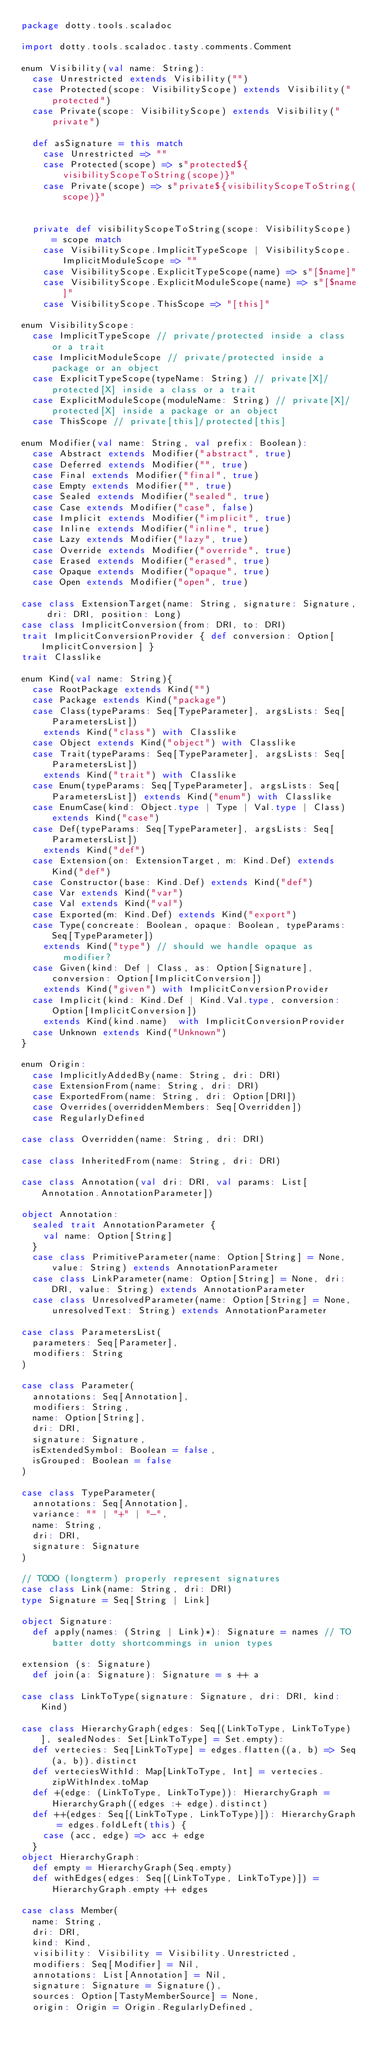Convert code to text. <code><loc_0><loc_0><loc_500><loc_500><_Scala_>package dotty.tools.scaladoc

import dotty.tools.scaladoc.tasty.comments.Comment

enum Visibility(val name: String):
  case Unrestricted extends Visibility("")
  case Protected(scope: VisibilityScope) extends Visibility("protected")
  case Private(scope: VisibilityScope) extends Visibility("private")

  def asSignature = this match
    case Unrestricted => ""
    case Protected(scope) => s"protected${visibilityScopeToString(scope)}"
    case Private(scope) => s"private${visibilityScopeToString(scope)}"


  private def visibilityScopeToString(scope: VisibilityScope) = scope match
    case VisibilityScope.ImplicitTypeScope | VisibilityScope.ImplicitModuleScope => ""
    case VisibilityScope.ExplicitTypeScope(name) => s"[$name]"
    case VisibilityScope.ExplicitModuleScope(name) => s"[$name]"
    case VisibilityScope.ThisScope => "[this]"

enum VisibilityScope:
  case ImplicitTypeScope // private/protected inside a class or a trait
  case ImplicitModuleScope // private/protected inside a package or an object
  case ExplicitTypeScope(typeName: String) // private[X]/protected[X] inside a class or a trait
  case ExplicitModuleScope(moduleName: String) // private[X]/protected[X] inside a package or an object
  case ThisScope // private[this]/protected[this]

enum Modifier(val name: String, val prefix: Boolean):
  case Abstract extends Modifier("abstract", true)
  case Deferred extends Modifier("", true)
  case Final extends Modifier("final", true)
  case Empty extends Modifier("", true)
  case Sealed extends Modifier("sealed", true)
  case Case extends Modifier("case", false)
  case Implicit extends Modifier("implicit", true)
  case Inline extends Modifier("inline", true)
  case Lazy extends Modifier("lazy", true)
  case Override extends Modifier("override", true)
  case Erased extends Modifier("erased", true)
  case Opaque extends Modifier("opaque", true)
  case Open extends Modifier("open", true)

case class ExtensionTarget(name: String, signature: Signature, dri: DRI, position: Long)
case class ImplicitConversion(from: DRI, to: DRI)
trait ImplicitConversionProvider { def conversion: Option[ImplicitConversion] }
trait Classlike

enum Kind(val name: String){
  case RootPackage extends Kind("")
  case Package extends Kind("package")
  case Class(typeParams: Seq[TypeParameter], argsLists: Seq[ParametersList])
    extends Kind("class") with Classlike
  case Object extends Kind("object") with Classlike
  case Trait(typeParams: Seq[TypeParameter], argsLists: Seq[ParametersList])
    extends Kind("trait") with Classlike
  case Enum(typeParams: Seq[TypeParameter], argsLists: Seq[ParametersList]) extends Kind("enum") with Classlike
  case EnumCase(kind: Object.type | Type | Val.type | Class) extends Kind("case")
  case Def(typeParams: Seq[TypeParameter], argsLists: Seq[ParametersList])
    extends Kind("def")
  case Extension(on: ExtensionTarget, m: Kind.Def) extends Kind("def")
  case Constructor(base: Kind.Def) extends Kind("def")
  case Var extends Kind("var")
  case Val extends Kind("val")
  case Exported(m: Kind.Def) extends Kind("export")
  case Type(concreate: Boolean, opaque: Boolean, typeParams: Seq[TypeParameter])
    extends Kind("type") // should we handle opaque as modifier?
  case Given(kind: Def | Class, as: Option[Signature], conversion: Option[ImplicitConversion])
    extends Kind("given") with ImplicitConversionProvider
  case Implicit(kind: Kind.Def | Kind.Val.type, conversion: Option[ImplicitConversion])
    extends Kind(kind.name)  with ImplicitConversionProvider
  case Unknown extends Kind("Unknown")
}

enum Origin:
  case ImplicitlyAddedBy(name: String, dri: DRI)
  case ExtensionFrom(name: String, dri: DRI)
  case ExportedFrom(name: String, dri: Option[DRI])
  case Overrides(overriddenMembers: Seq[Overridden])
  case RegularlyDefined

case class Overridden(name: String, dri: DRI)

case class InheritedFrom(name: String, dri: DRI)

case class Annotation(val dri: DRI, val params: List[Annotation.AnnotationParameter])

object Annotation:
  sealed trait AnnotationParameter {
    val name: Option[String]
  }
  case class PrimitiveParameter(name: Option[String] = None, value: String) extends AnnotationParameter
  case class LinkParameter(name: Option[String] = None, dri: DRI, value: String) extends AnnotationParameter
  case class UnresolvedParameter(name: Option[String] = None, unresolvedText: String) extends AnnotationParameter

case class ParametersList(
  parameters: Seq[Parameter],
  modifiers: String
)

case class Parameter(
  annotations: Seq[Annotation],
  modifiers: String,
  name: Option[String],
  dri: DRI,
  signature: Signature,
  isExtendedSymbol: Boolean = false,
  isGrouped: Boolean = false
)

case class TypeParameter(
  annotations: Seq[Annotation],
  variance: "" | "+" | "-",
  name: String,
  dri: DRI,
  signature: Signature
)

// TODO (longterm) properly represent signatures
case class Link(name: String, dri: DRI)
type Signature = Seq[String | Link]

object Signature:
  def apply(names: (String | Link)*): Signature = names // TO batter dotty shortcommings in union types

extension (s: Signature)
  def join(a: Signature): Signature = s ++ a

case class LinkToType(signature: Signature, dri: DRI, kind: Kind)

case class HierarchyGraph(edges: Seq[(LinkToType, LinkToType)], sealedNodes: Set[LinkToType] = Set.empty):
  def vertecies: Seq[LinkToType] = edges.flatten((a, b) => Seq(a, b)).distinct
  def verteciesWithId: Map[LinkToType, Int] = vertecies.zipWithIndex.toMap
  def +(edge: (LinkToType, LinkToType)): HierarchyGraph = HierarchyGraph((edges :+ edge).distinct)
  def ++(edges: Seq[(LinkToType, LinkToType)]): HierarchyGraph = edges.foldLeft(this) {
    case (acc, edge) => acc + edge
  }
object HierarchyGraph:
  def empty = HierarchyGraph(Seq.empty)
  def withEdges(edges: Seq[(LinkToType, LinkToType)]) = HierarchyGraph.empty ++ edges

case class Member(
  name: String,
  dri: DRI,
  kind: Kind,
  visibility: Visibility = Visibility.Unrestricted,
  modifiers: Seq[Modifier] = Nil,
  annotations: List[Annotation] = Nil,
  signature: Signature = Signature(),
  sources: Option[TastyMemberSource] = None,
  origin: Origin = Origin.RegularlyDefined,</code> 